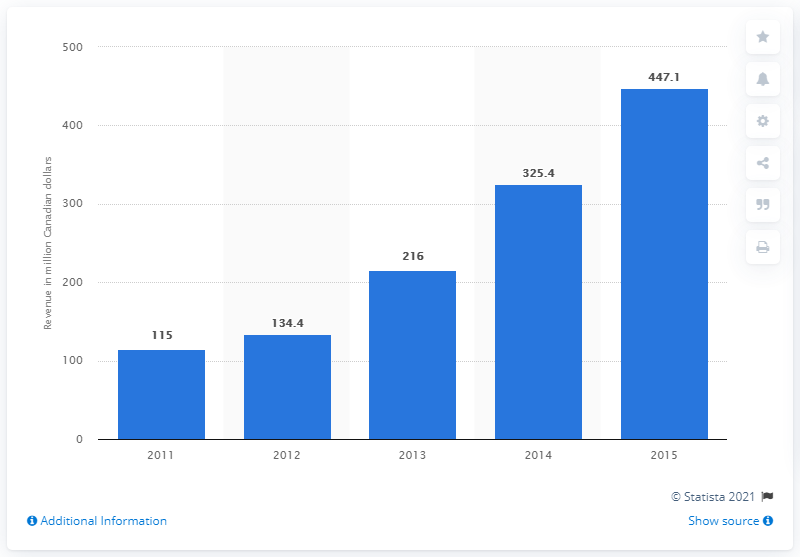List a handful of essential elements in this visual. Netflix generated an estimated revenue of CAD 447.1 million in Canada between 2011 and 2015. 